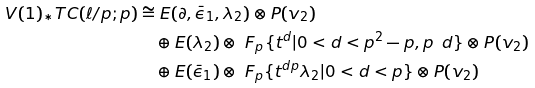<formula> <loc_0><loc_0><loc_500><loc_500>V ( 1 ) _ { * } T C ( \ell / p ; p ) & \cong E ( \partial , \bar { \epsilon } _ { 1 } , \lambda _ { 2 } ) \otimes P ( v _ { 2 } ) \\ & \quad \oplus E ( \lambda _ { 2 } ) \otimes \ F _ { p } \{ t ^ { d } | 0 < d < p ^ { 2 } - p , p \nmid d \} \otimes P ( v _ { 2 } ) \\ & \quad \oplus E ( \bar { \epsilon } _ { 1 } ) \otimes \ F _ { p } \{ t ^ { d p } \lambda _ { 2 } | 0 < d < p \} \otimes P ( v _ { 2 } )</formula> 